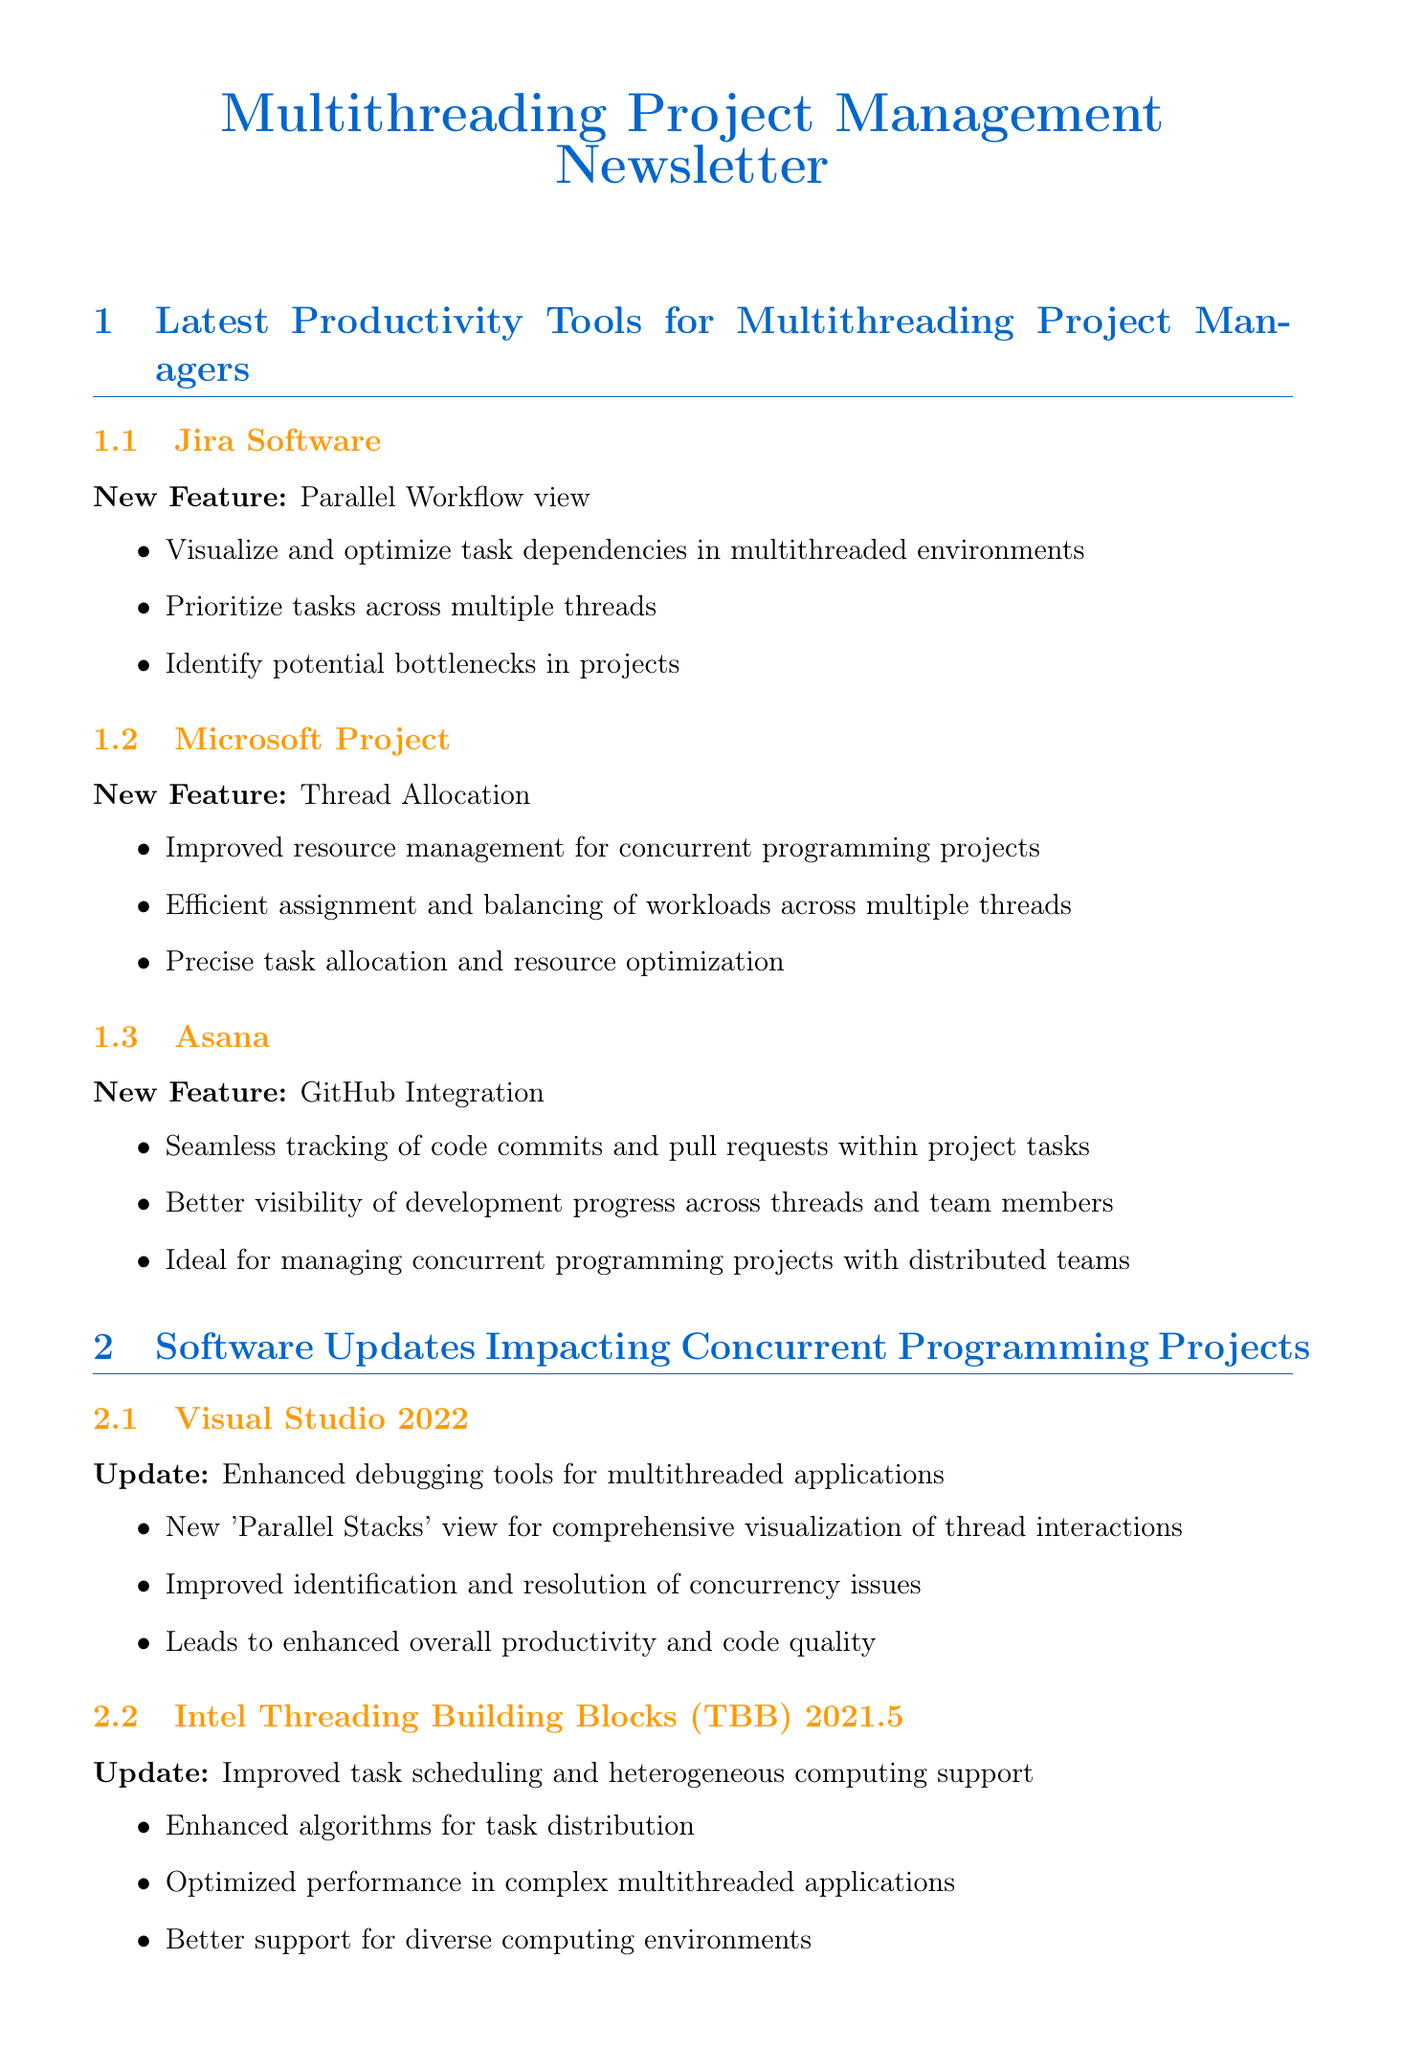What new view has Jira Software introduced? The document states that Jira Software has introduced the 'Parallel Workflow' view to help project managers visualize and optimize task dependencies in multithreaded environments.
Answer: Parallel Workflow What new feature has been added to Microsoft Project? The latest update to Microsoft Project includes the new 'Thread Allocation' feature which helps in the efficient assignment and balancing of workloads.
Answer: Thread Allocation Which tool has a new integration with GitHub? Asana has launched a new integration with GitHub to enable seamless tracking of code commits and pull requests.
Answer: Asana What significant update has Visual Studio 2022 received? The document mentions that the significant update to Visual Studio 2022 includes enhanced debugging tools for multithreaded applications, specifically the new 'Parallel Stacks' view.
Answer: Parallel Stacks What is the benefit of regular code reviews? The document states that conducting regular code reviews helps maintain high code quality and prevent potential concurrency-related bugs before they make it into production.
Answer: High code quality Which software version of Intel TBB was mentioned in the updates? The document specifies that version 2021.5 of Intel Threading Building Blocks (TBB) has been launched with improved task scheduling algorithms.
Answer: 2021.5 What practice encourages using ConcurrentHashMap and AtomicInteger? The document promotes the practice of implementing thread-safe data structures to minimize synchronization issues in multithreaded applications.
Answer: Implement thread-safe data structures How do thread pools improve application performance? The document explains that utilizing thread pools allows for efficient management of thread creation and reuse, leading to improved application performance and resource utilization.
Answer: Improve application performance What type of projects benefits from the new Jenkins plugins? The new Jenkins plugins are specifically designed for concurrent build management and parallel testing in CI/CD pipelines, which benefits multithreading projects.
Answer: Multithreading projects 